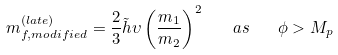<formula> <loc_0><loc_0><loc_500><loc_500>m ^ { ( l a t e ) } _ { f , m o d i f i e d } = \frac { 2 } { 3 } \tilde { h } \upsilon \left ( \frac { m _ { 1 } } { m _ { 2 } } \right ) ^ { 2 } \quad a s \quad \phi > M _ { p }</formula> 